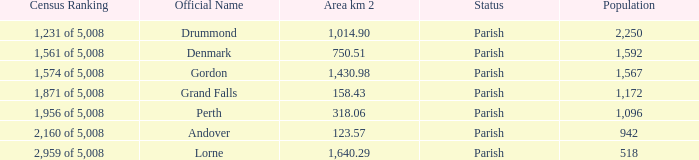Which parish has an area of 750.51? Denmark. 